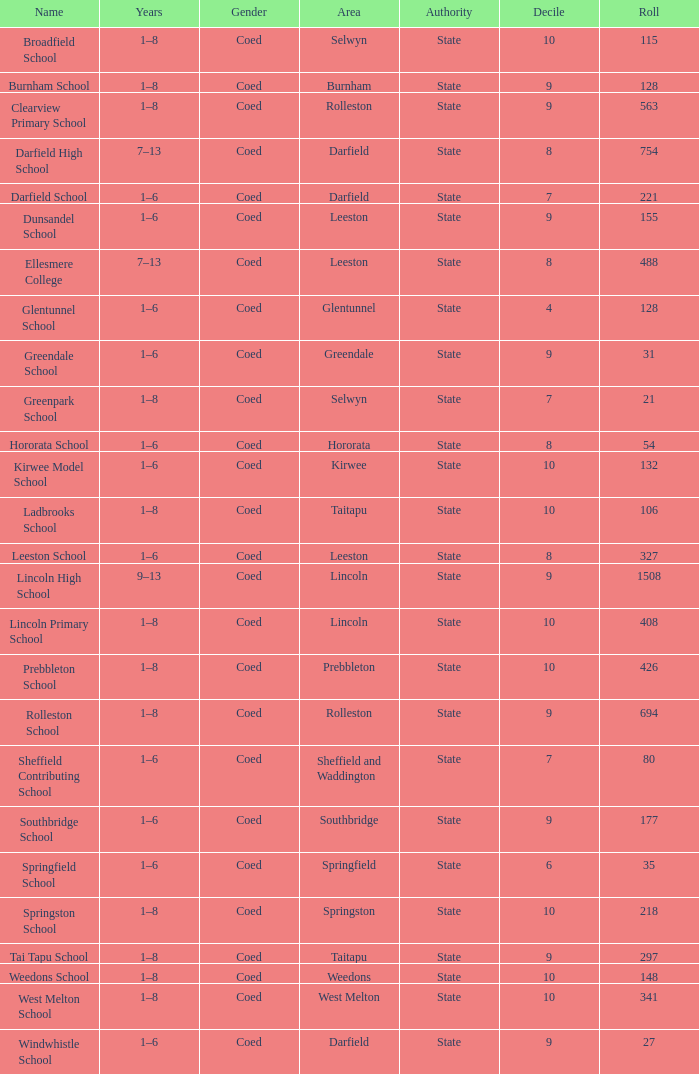What is the name with a Decile less than 10, and a Roll of 297? Tai Tapu School. 